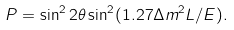<formula> <loc_0><loc_0><loc_500><loc_500>P = \sin ^ { 2 } 2 \theta \sin ^ { 2 } ( 1 . 2 7 \Delta m ^ { 2 } L / E ) .</formula> 